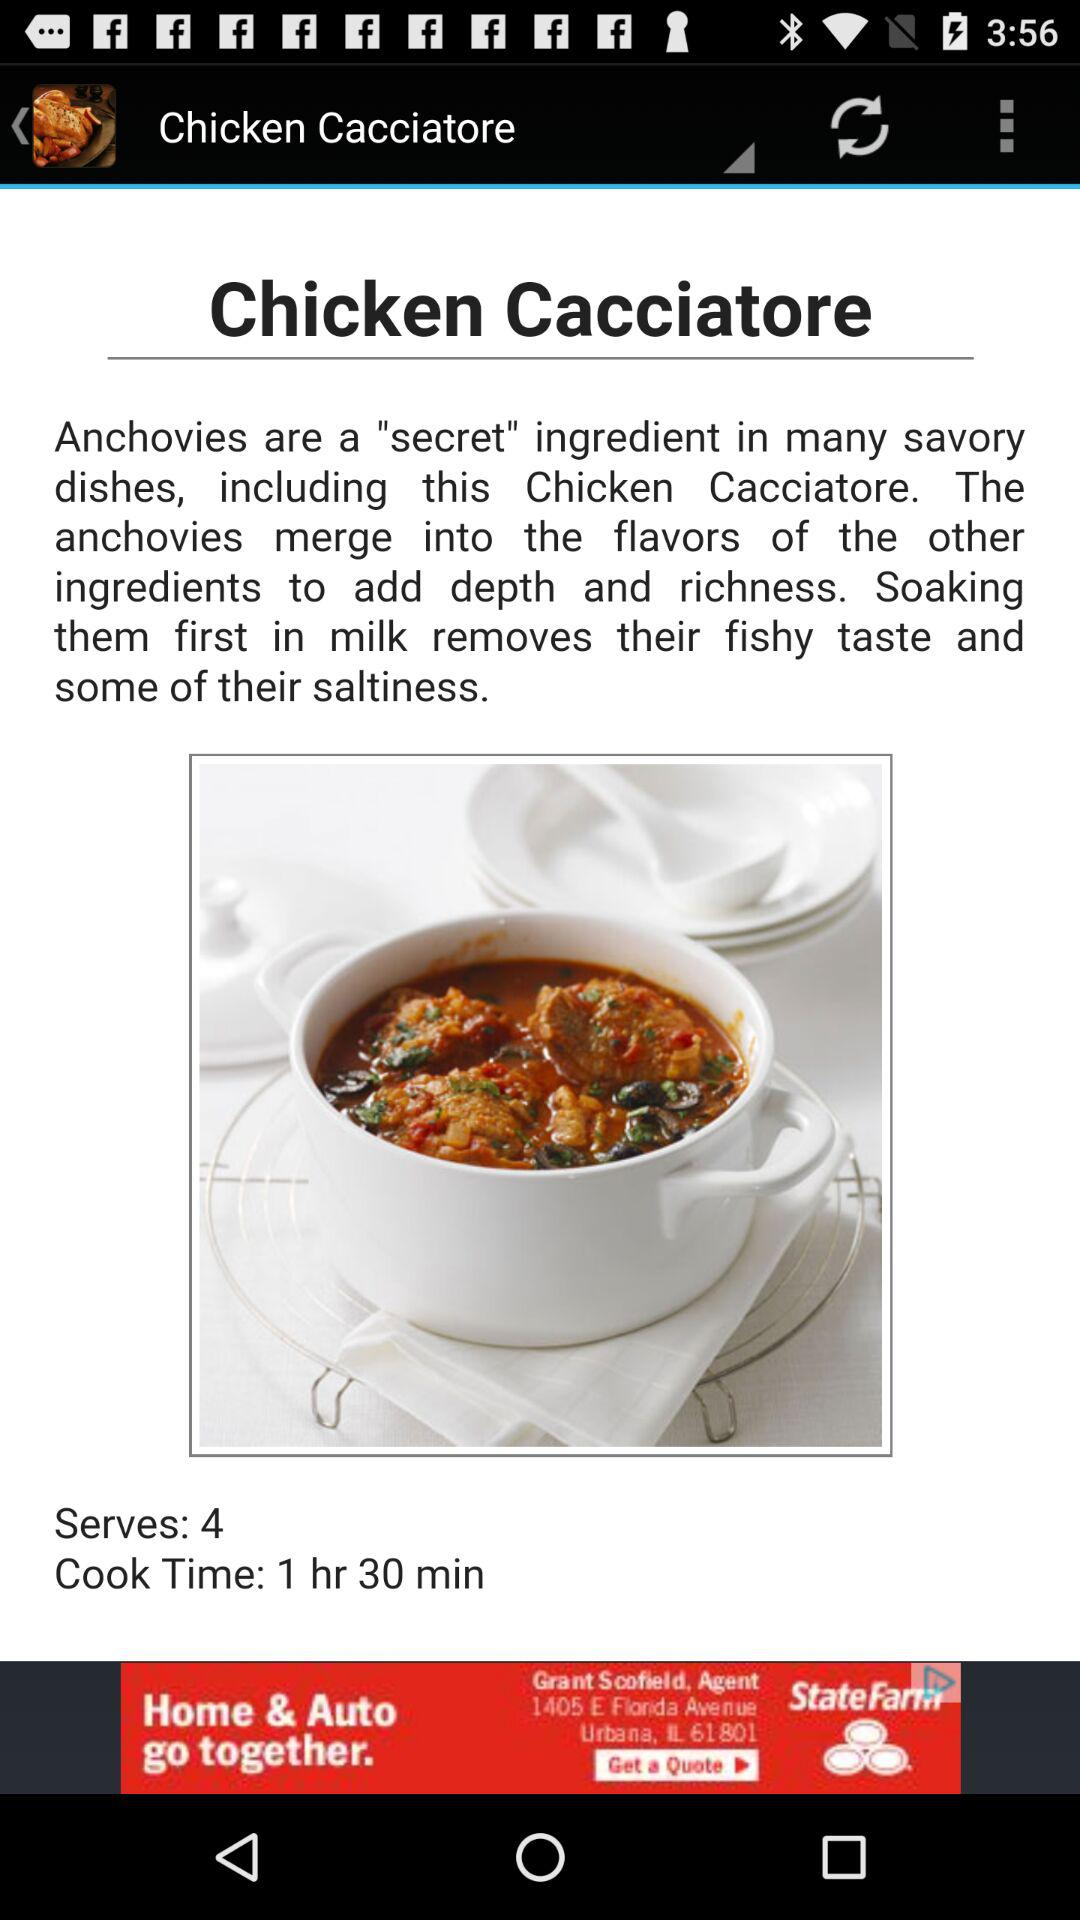How many people can the dish be served to? The dish can be served to 4 people. 